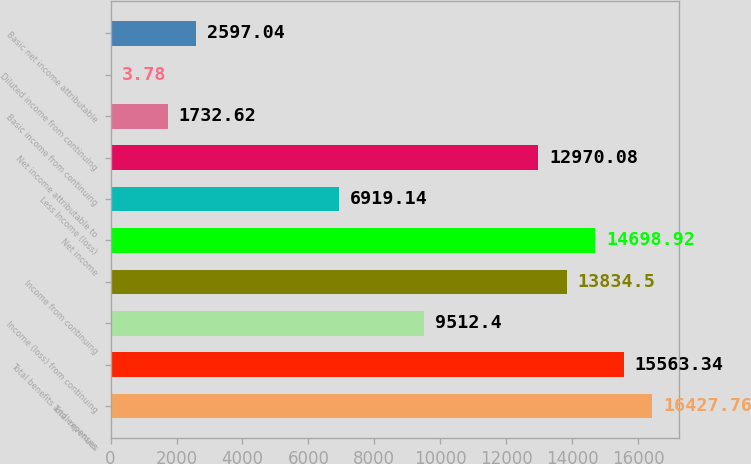Convert chart to OTSL. <chart><loc_0><loc_0><loc_500><loc_500><bar_chart><fcel>Total revenues<fcel>Total benefits and expenses<fcel>Income (loss) from continuing<fcel>Income from continuing<fcel>Net income<fcel>Less Income (loss)<fcel>Net income attributable to<fcel>Basic income from continuing<fcel>Diluted income from continuing<fcel>Basic net income attributable<nl><fcel>16427.8<fcel>15563.3<fcel>9512.4<fcel>13834.5<fcel>14698.9<fcel>6919.14<fcel>12970.1<fcel>1732.62<fcel>3.78<fcel>2597.04<nl></chart> 